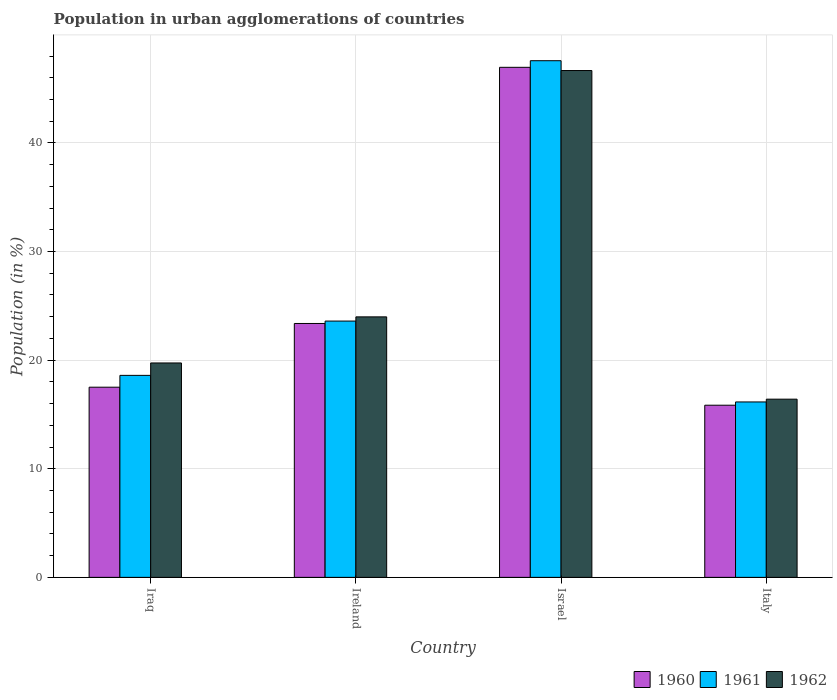How many different coloured bars are there?
Provide a succinct answer. 3. How many groups of bars are there?
Your answer should be compact. 4. Are the number of bars per tick equal to the number of legend labels?
Ensure brevity in your answer.  Yes. Are the number of bars on each tick of the X-axis equal?
Your answer should be compact. Yes. How many bars are there on the 1st tick from the left?
Keep it short and to the point. 3. How many bars are there on the 1st tick from the right?
Offer a terse response. 3. What is the label of the 3rd group of bars from the left?
Keep it short and to the point. Israel. In how many cases, is the number of bars for a given country not equal to the number of legend labels?
Keep it short and to the point. 0. What is the percentage of population in urban agglomerations in 1960 in Israel?
Keep it short and to the point. 46.96. Across all countries, what is the maximum percentage of population in urban agglomerations in 1960?
Your answer should be compact. 46.96. Across all countries, what is the minimum percentage of population in urban agglomerations in 1960?
Give a very brief answer. 15.85. What is the total percentage of population in urban agglomerations in 1961 in the graph?
Ensure brevity in your answer.  105.92. What is the difference between the percentage of population in urban agglomerations in 1961 in Iraq and that in Italy?
Your response must be concise. 2.45. What is the difference between the percentage of population in urban agglomerations in 1960 in Ireland and the percentage of population in urban agglomerations in 1961 in Iraq?
Your answer should be very brief. 4.78. What is the average percentage of population in urban agglomerations in 1961 per country?
Keep it short and to the point. 26.48. What is the difference between the percentage of population in urban agglomerations of/in 1961 and percentage of population in urban agglomerations of/in 1960 in Ireland?
Your response must be concise. 0.22. In how many countries, is the percentage of population in urban agglomerations in 1960 greater than 40 %?
Ensure brevity in your answer.  1. What is the ratio of the percentage of population in urban agglomerations in 1962 in Iraq to that in Israel?
Give a very brief answer. 0.42. Is the percentage of population in urban agglomerations in 1960 in Ireland less than that in Israel?
Offer a terse response. Yes. What is the difference between the highest and the second highest percentage of population in urban agglomerations in 1962?
Provide a succinct answer. -26.92. What is the difference between the highest and the lowest percentage of population in urban agglomerations in 1962?
Offer a terse response. 30.26. In how many countries, is the percentage of population in urban agglomerations in 1962 greater than the average percentage of population in urban agglomerations in 1962 taken over all countries?
Ensure brevity in your answer.  1. What does the 2nd bar from the left in Italy represents?
Provide a succinct answer. 1961. What does the 1st bar from the right in Israel represents?
Make the answer very short. 1962. Is it the case that in every country, the sum of the percentage of population in urban agglomerations in 1960 and percentage of population in urban agglomerations in 1962 is greater than the percentage of population in urban agglomerations in 1961?
Your answer should be compact. Yes. How many bars are there?
Offer a terse response. 12. Are all the bars in the graph horizontal?
Make the answer very short. No. What is the difference between two consecutive major ticks on the Y-axis?
Provide a short and direct response. 10. Are the values on the major ticks of Y-axis written in scientific E-notation?
Give a very brief answer. No. Does the graph contain any zero values?
Provide a short and direct response. No. Where does the legend appear in the graph?
Offer a terse response. Bottom right. How are the legend labels stacked?
Make the answer very short. Horizontal. What is the title of the graph?
Your answer should be very brief. Population in urban agglomerations of countries. Does "1984" appear as one of the legend labels in the graph?
Give a very brief answer. No. What is the label or title of the X-axis?
Your answer should be compact. Country. What is the Population (in %) in 1960 in Iraq?
Offer a very short reply. 17.51. What is the Population (in %) in 1961 in Iraq?
Provide a succinct answer. 18.6. What is the Population (in %) of 1962 in Iraq?
Offer a terse response. 19.74. What is the Population (in %) of 1960 in Ireland?
Ensure brevity in your answer.  23.38. What is the Population (in %) of 1961 in Ireland?
Your answer should be compact. 23.6. What is the Population (in %) of 1962 in Ireland?
Your response must be concise. 23.98. What is the Population (in %) in 1960 in Israel?
Offer a terse response. 46.96. What is the Population (in %) in 1961 in Israel?
Give a very brief answer. 47.57. What is the Population (in %) of 1962 in Israel?
Keep it short and to the point. 46.67. What is the Population (in %) of 1960 in Italy?
Provide a short and direct response. 15.85. What is the Population (in %) of 1961 in Italy?
Your answer should be compact. 16.15. What is the Population (in %) in 1962 in Italy?
Offer a very short reply. 16.41. Across all countries, what is the maximum Population (in %) in 1960?
Your answer should be very brief. 46.96. Across all countries, what is the maximum Population (in %) in 1961?
Make the answer very short. 47.57. Across all countries, what is the maximum Population (in %) of 1962?
Your response must be concise. 46.67. Across all countries, what is the minimum Population (in %) of 1960?
Keep it short and to the point. 15.85. Across all countries, what is the minimum Population (in %) in 1961?
Make the answer very short. 16.15. Across all countries, what is the minimum Population (in %) in 1962?
Give a very brief answer. 16.41. What is the total Population (in %) of 1960 in the graph?
Offer a very short reply. 103.7. What is the total Population (in %) of 1961 in the graph?
Make the answer very short. 105.92. What is the total Population (in %) in 1962 in the graph?
Offer a very short reply. 106.8. What is the difference between the Population (in %) of 1960 in Iraq and that in Ireland?
Give a very brief answer. -5.87. What is the difference between the Population (in %) of 1961 in Iraq and that in Ireland?
Make the answer very short. -5. What is the difference between the Population (in %) in 1962 in Iraq and that in Ireland?
Your answer should be compact. -4.24. What is the difference between the Population (in %) of 1960 in Iraq and that in Israel?
Your response must be concise. -29.45. What is the difference between the Population (in %) of 1961 in Iraq and that in Israel?
Provide a short and direct response. -28.97. What is the difference between the Population (in %) in 1962 in Iraq and that in Israel?
Offer a very short reply. -26.92. What is the difference between the Population (in %) in 1960 in Iraq and that in Italy?
Provide a short and direct response. 1.66. What is the difference between the Population (in %) in 1961 in Iraq and that in Italy?
Provide a short and direct response. 2.45. What is the difference between the Population (in %) of 1962 in Iraq and that in Italy?
Your response must be concise. 3.33. What is the difference between the Population (in %) of 1960 in Ireland and that in Israel?
Your response must be concise. -23.59. What is the difference between the Population (in %) in 1961 in Ireland and that in Israel?
Your response must be concise. -23.97. What is the difference between the Population (in %) in 1962 in Ireland and that in Israel?
Keep it short and to the point. -22.68. What is the difference between the Population (in %) in 1960 in Ireland and that in Italy?
Make the answer very short. 7.53. What is the difference between the Population (in %) of 1961 in Ireland and that in Italy?
Offer a very short reply. 7.45. What is the difference between the Population (in %) of 1962 in Ireland and that in Italy?
Provide a succinct answer. 7.58. What is the difference between the Population (in %) of 1960 in Israel and that in Italy?
Keep it short and to the point. 31.11. What is the difference between the Population (in %) of 1961 in Israel and that in Italy?
Provide a succinct answer. 31.42. What is the difference between the Population (in %) in 1962 in Israel and that in Italy?
Offer a very short reply. 30.26. What is the difference between the Population (in %) of 1960 in Iraq and the Population (in %) of 1961 in Ireland?
Provide a short and direct response. -6.09. What is the difference between the Population (in %) in 1960 in Iraq and the Population (in %) in 1962 in Ireland?
Provide a succinct answer. -6.48. What is the difference between the Population (in %) of 1961 in Iraq and the Population (in %) of 1962 in Ireland?
Offer a very short reply. -5.39. What is the difference between the Population (in %) in 1960 in Iraq and the Population (in %) in 1961 in Israel?
Your response must be concise. -30.06. What is the difference between the Population (in %) in 1960 in Iraq and the Population (in %) in 1962 in Israel?
Offer a terse response. -29.16. What is the difference between the Population (in %) of 1961 in Iraq and the Population (in %) of 1962 in Israel?
Your response must be concise. -28.07. What is the difference between the Population (in %) in 1960 in Iraq and the Population (in %) in 1961 in Italy?
Provide a short and direct response. 1.36. What is the difference between the Population (in %) of 1960 in Iraq and the Population (in %) of 1962 in Italy?
Keep it short and to the point. 1.1. What is the difference between the Population (in %) of 1961 in Iraq and the Population (in %) of 1962 in Italy?
Your response must be concise. 2.19. What is the difference between the Population (in %) of 1960 in Ireland and the Population (in %) of 1961 in Israel?
Your answer should be very brief. -24.19. What is the difference between the Population (in %) in 1960 in Ireland and the Population (in %) in 1962 in Israel?
Your answer should be very brief. -23.29. What is the difference between the Population (in %) of 1961 in Ireland and the Population (in %) of 1962 in Israel?
Your answer should be very brief. -23.07. What is the difference between the Population (in %) in 1960 in Ireland and the Population (in %) in 1961 in Italy?
Your answer should be compact. 7.23. What is the difference between the Population (in %) of 1960 in Ireland and the Population (in %) of 1962 in Italy?
Make the answer very short. 6.97. What is the difference between the Population (in %) in 1961 in Ireland and the Population (in %) in 1962 in Italy?
Your response must be concise. 7.19. What is the difference between the Population (in %) in 1960 in Israel and the Population (in %) in 1961 in Italy?
Keep it short and to the point. 30.81. What is the difference between the Population (in %) of 1960 in Israel and the Population (in %) of 1962 in Italy?
Your answer should be compact. 30.55. What is the difference between the Population (in %) of 1961 in Israel and the Population (in %) of 1962 in Italy?
Your response must be concise. 31.16. What is the average Population (in %) of 1960 per country?
Keep it short and to the point. 25.92. What is the average Population (in %) of 1961 per country?
Provide a succinct answer. 26.48. What is the average Population (in %) in 1962 per country?
Keep it short and to the point. 26.7. What is the difference between the Population (in %) of 1960 and Population (in %) of 1961 in Iraq?
Offer a very short reply. -1.09. What is the difference between the Population (in %) in 1960 and Population (in %) in 1962 in Iraq?
Give a very brief answer. -2.23. What is the difference between the Population (in %) in 1961 and Population (in %) in 1962 in Iraq?
Give a very brief answer. -1.14. What is the difference between the Population (in %) in 1960 and Population (in %) in 1961 in Ireland?
Your answer should be very brief. -0.22. What is the difference between the Population (in %) in 1960 and Population (in %) in 1962 in Ireland?
Ensure brevity in your answer.  -0.61. What is the difference between the Population (in %) of 1961 and Population (in %) of 1962 in Ireland?
Make the answer very short. -0.39. What is the difference between the Population (in %) in 1960 and Population (in %) in 1961 in Israel?
Your response must be concise. -0.61. What is the difference between the Population (in %) of 1960 and Population (in %) of 1962 in Israel?
Offer a terse response. 0.3. What is the difference between the Population (in %) in 1961 and Population (in %) in 1962 in Israel?
Give a very brief answer. 0.9. What is the difference between the Population (in %) of 1960 and Population (in %) of 1961 in Italy?
Keep it short and to the point. -0.3. What is the difference between the Population (in %) in 1960 and Population (in %) in 1962 in Italy?
Keep it short and to the point. -0.56. What is the difference between the Population (in %) of 1961 and Population (in %) of 1962 in Italy?
Offer a terse response. -0.26. What is the ratio of the Population (in %) of 1960 in Iraq to that in Ireland?
Keep it short and to the point. 0.75. What is the ratio of the Population (in %) of 1961 in Iraq to that in Ireland?
Offer a terse response. 0.79. What is the ratio of the Population (in %) in 1962 in Iraq to that in Ireland?
Provide a succinct answer. 0.82. What is the ratio of the Population (in %) of 1960 in Iraq to that in Israel?
Your answer should be compact. 0.37. What is the ratio of the Population (in %) in 1961 in Iraq to that in Israel?
Provide a short and direct response. 0.39. What is the ratio of the Population (in %) of 1962 in Iraq to that in Israel?
Your answer should be compact. 0.42. What is the ratio of the Population (in %) in 1960 in Iraq to that in Italy?
Provide a short and direct response. 1.1. What is the ratio of the Population (in %) of 1961 in Iraq to that in Italy?
Your answer should be compact. 1.15. What is the ratio of the Population (in %) in 1962 in Iraq to that in Italy?
Offer a very short reply. 1.2. What is the ratio of the Population (in %) of 1960 in Ireland to that in Israel?
Provide a short and direct response. 0.5. What is the ratio of the Population (in %) of 1961 in Ireland to that in Israel?
Your answer should be very brief. 0.5. What is the ratio of the Population (in %) of 1962 in Ireland to that in Israel?
Provide a short and direct response. 0.51. What is the ratio of the Population (in %) in 1960 in Ireland to that in Italy?
Offer a terse response. 1.47. What is the ratio of the Population (in %) of 1961 in Ireland to that in Italy?
Keep it short and to the point. 1.46. What is the ratio of the Population (in %) of 1962 in Ireland to that in Italy?
Offer a very short reply. 1.46. What is the ratio of the Population (in %) of 1960 in Israel to that in Italy?
Make the answer very short. 2.96. What is the ratio of the Population (in %) of 1961 in Israel to that in Italy?
Ensure brevity in your answer.  2.95. What is the ratio of the Population (in %) of 1962 in Israel to that in Italy?
Provide a succinct answer. 2.84. What is the difference between the highest and the second highest Population (in %) in 1960?
Keep it short and to the point. 23.59. What is the difference between the highest and the second highest Population (in %) of 1961?
Provide a short and direct response. 23.97. What is the difference between the highest and the second highest Population (in %) in 1962?
Provide a short and direct response. 22.68. What is the difference between the highest and the lowest Population (in %) of 1960?
Provide a short and direct response. 31.11. What is the difference between the highest and the lowest Population (in %) in 1961?
Keep it short and to the point. 31.42. What is the difference between the highest and the lowest Population (in %) in 1962?
Offer a terse response. 30.26. 